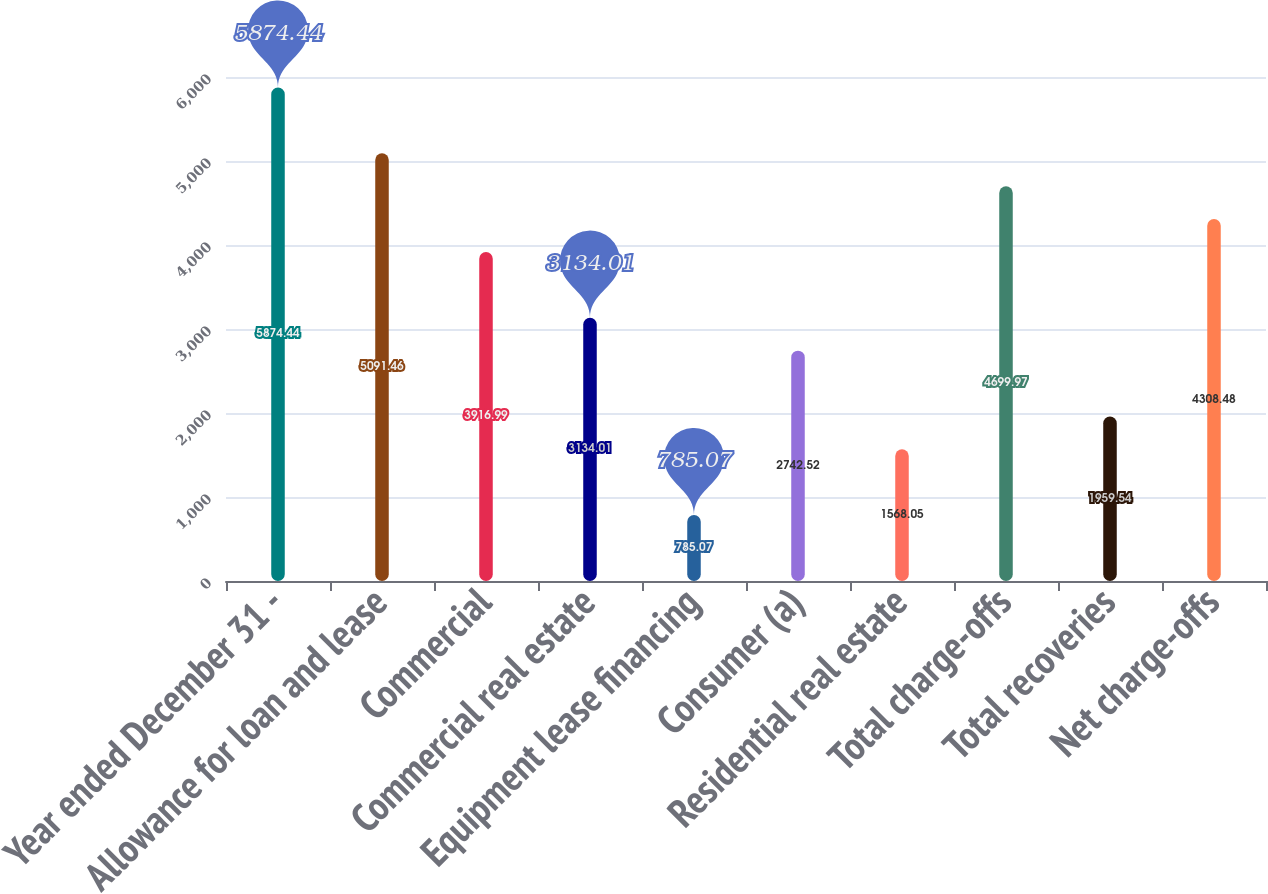Convert chart. <chart><loc_0><loc_0><loc_500><loc_500><bar_chart><fcel>Year ended December 31 -<fcel>Allowance for loan and lease<fcel>Commercial<fcel>Commercial real estate<fcel>Equipment lease financing<fcel>Consumer (a)<fcel>Residential real estate<fcel>Total charge-offs<fcel>Total recoveries<fcel>Net charge-offs<nl><fcel>5874.44<fcel>5091.46<fcel>3916.99<fcel>3134.01<fcel>785.07<fcel>2742.52<fcel>1568.05<fcel>4699.97<fcel>1959.54<fcel>4308.48<nl></chart> 